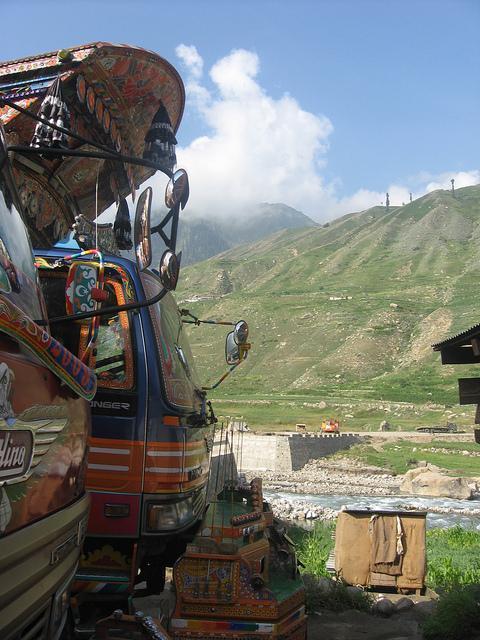How many buses are there?
Give a very brief answer. 2. 